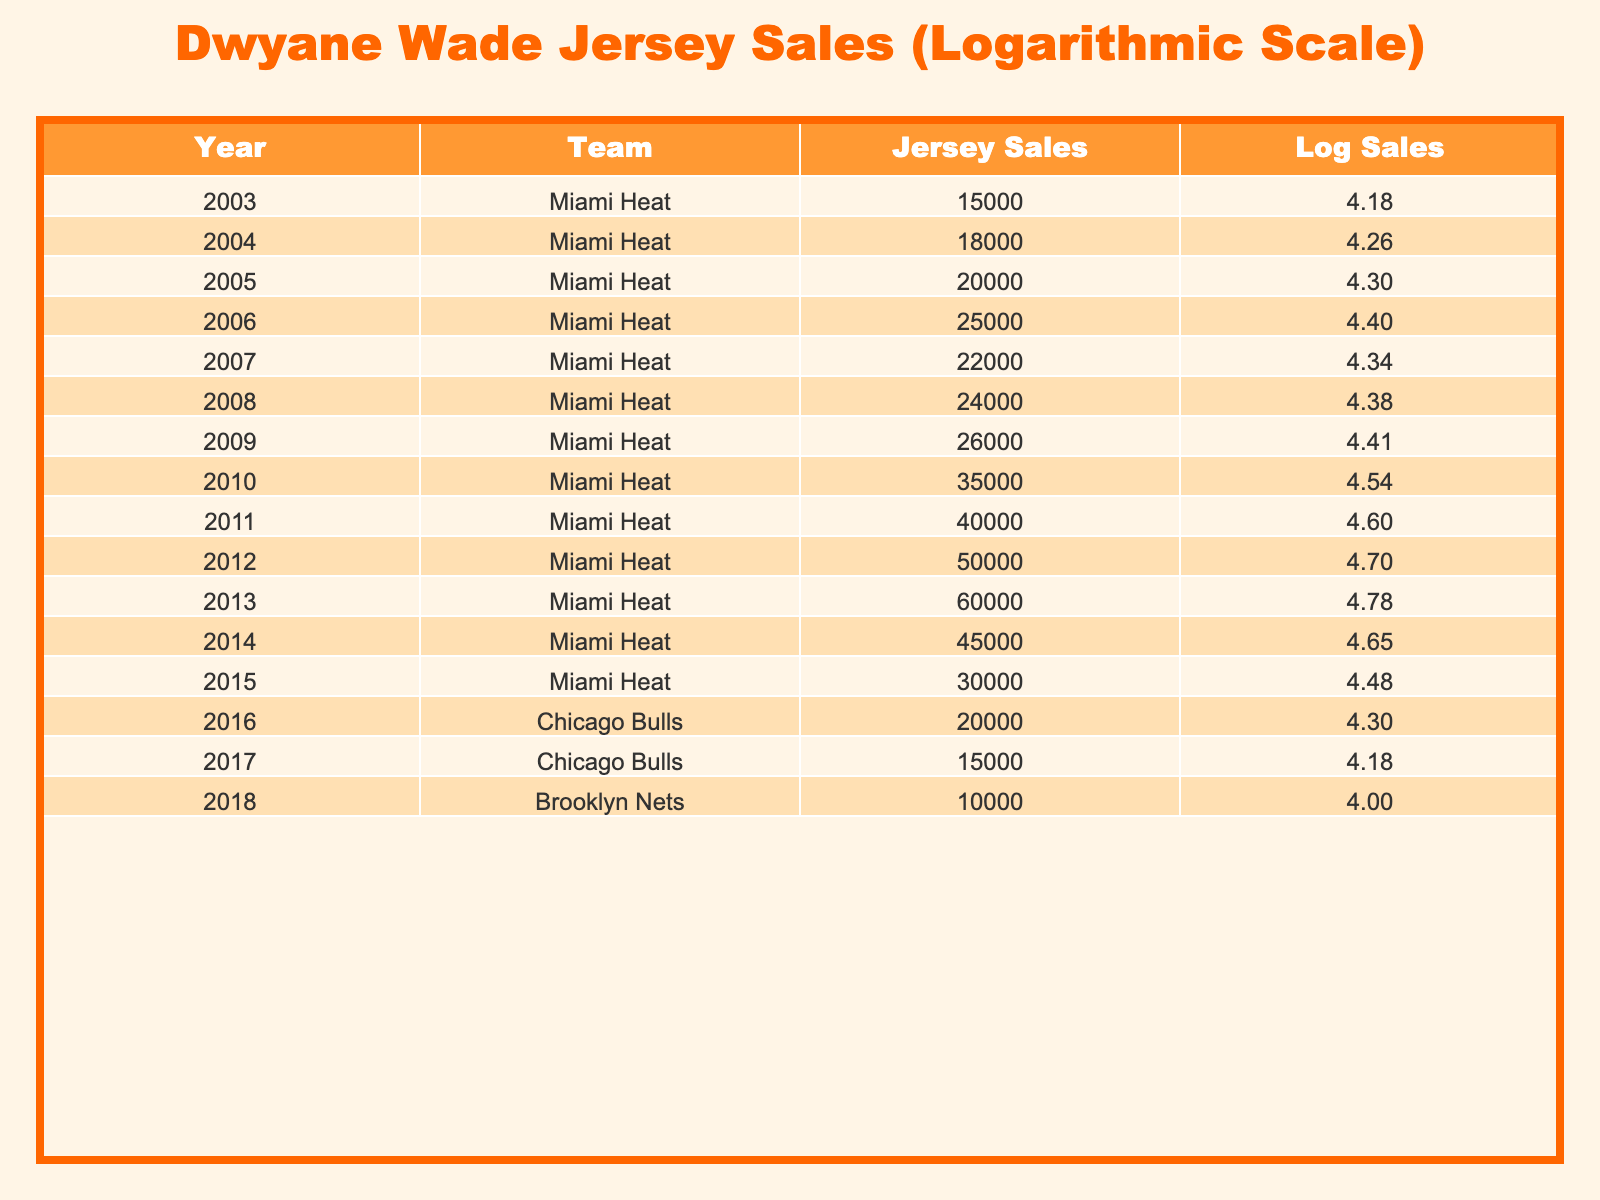What year had the highest jersey sales? By looking at the Jersey Sales column, the highest value is 60000, which corresponds to the year 2013.
Answer: 2013 What was the jersey sales figure for Dwyane Wade in 2006? The table shows that the jersey sales for the year 2006 were 25000.
Answer: 25000 How many total jersey sales were recorded from 2003 to 2009? We calculate the total by adding the figures: 15000 + 18000 + 20000 + 25000 + 22000 + 24000 + 26000 = 150000.
Answer: 150000 Did Dwyane Wade have jersey sales in 2018? The table shows that in 2018, the jersey sales were recorded under the Brooklyn Nets, not Miami Heat, where Wade played, so the answer is no.
Answer: No What is the difference in jersey sales between the years 2011 and 2015? The jersey sales in 2011 were 40000, and in 2015 they were 30000. The difference is 40000 - 30000 = 10000.
Answer: 10000 What is the average jersey sales for the years 2004 to 2010? The total sales from 2004 to 2010 are: 18000 + 20000 + 25000 + 22000 + 24000 + 26000 + 35000 = 175000. There are 7 years, so the average is 175000 / 7 = 25000.
Answer: 25000 In what year did jersey sales first exceed 30000? By checking the Jersey Sales column, we see that the first occurrence where sales exceed 30000 is in 2010, with sales of 35000.
Answer: 2010 Was the jersey sale figure for the Miami Heat higher in 2008 or in 2014? In 2008, the sales were 24000, and in 2014, they were 45000. Since 45000 is greater than 24000, the answer is yes, 2014 had higher sales.
Answer: Yes What was the log value of the jersey sales in 2012? The jersey sales in 2012 were 60000. The logarithmic value is calculated as log10(60000), which is approximately 4.78.
Answer: 4.78 